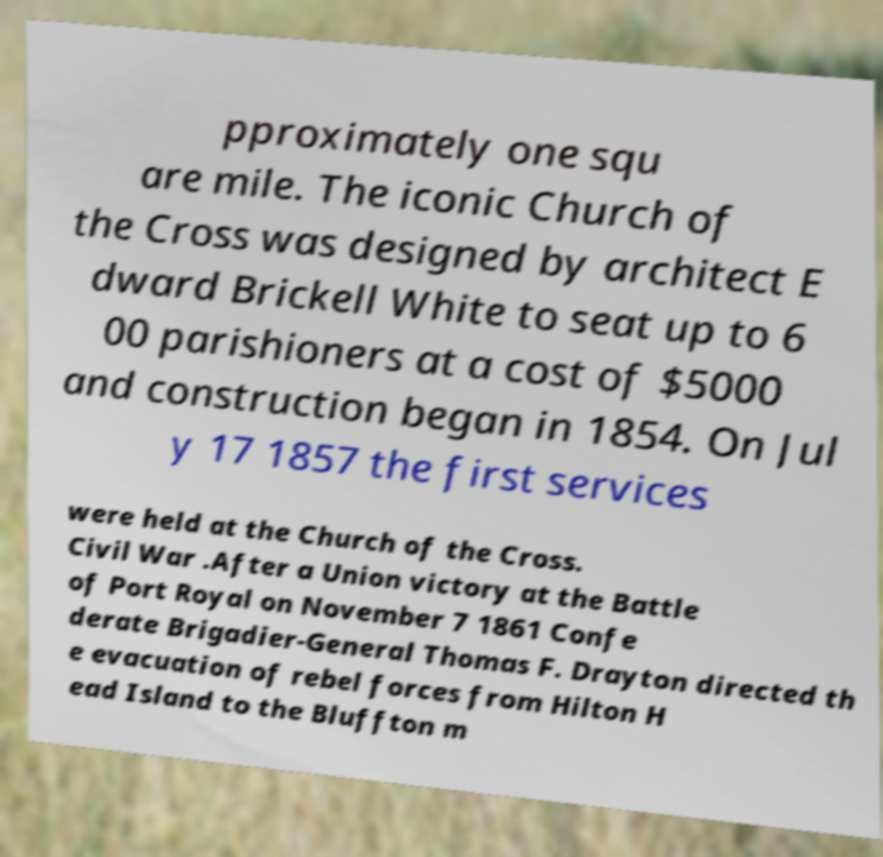Could you extract and type out the text from this image? pproximately one squ are mile. The iconic Church of the Cross was designed by architect E dward Brickell White to seat up to 6 00 parishioners at a cost of $5000 and construction began in 1854. On Jul y 17 1857 the first services were held at the Church of the Cross. Civil War .After a Union victory at the Battle of Port Royal on November 7 1861 Confe derate Brigadier-General Thomas F. Drayton directed th e evacuation of rebel forces from Hilton H ead Island to the Bluffton m 